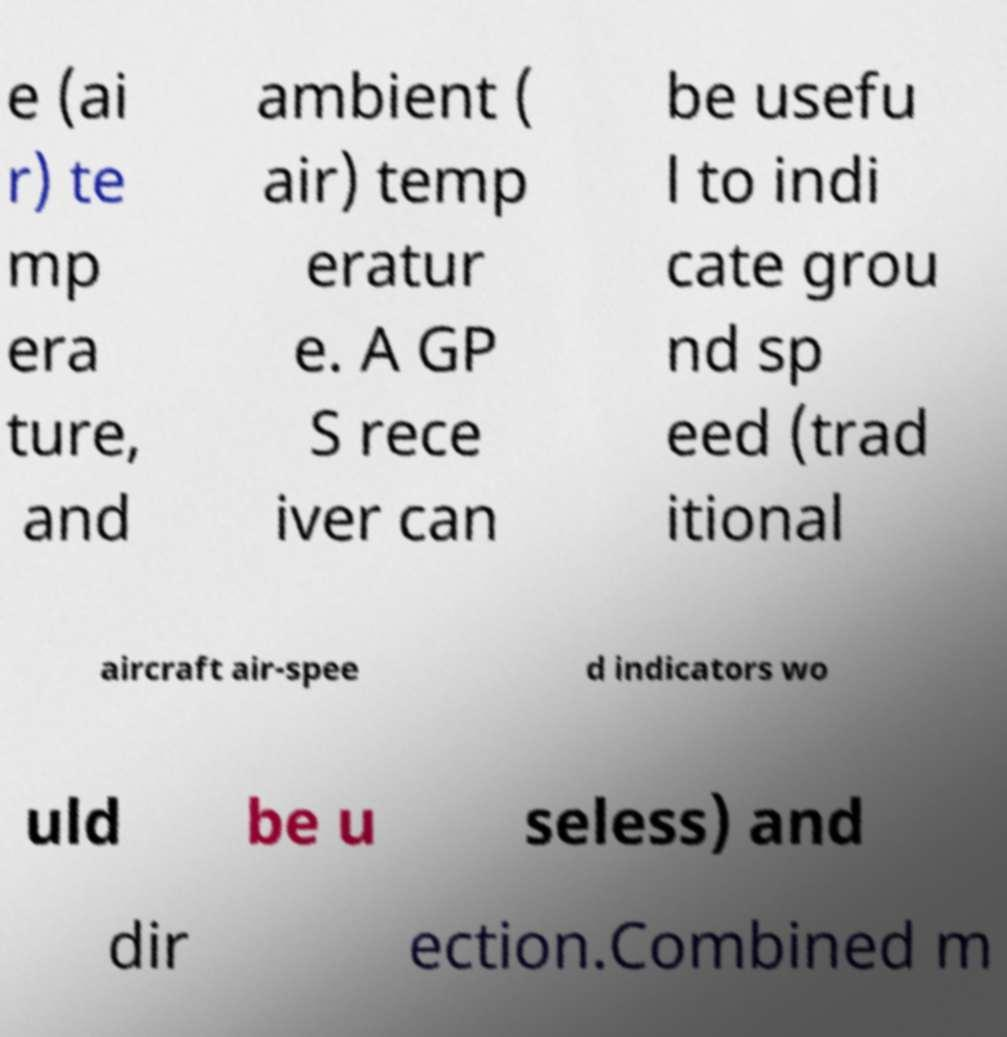Can you read and provide the text displayed in the image?This photo seems to have some interesting text. Can you extract and type it out for me? e (ai r) te mp era ture, and ambient ( air) temp eratur e. A GP S rece iver can be usefu l to indi cate grou nd sp eed (trad itional aircraft air-spee d indicators wo uld be u seless) and dir ection.Combined m 